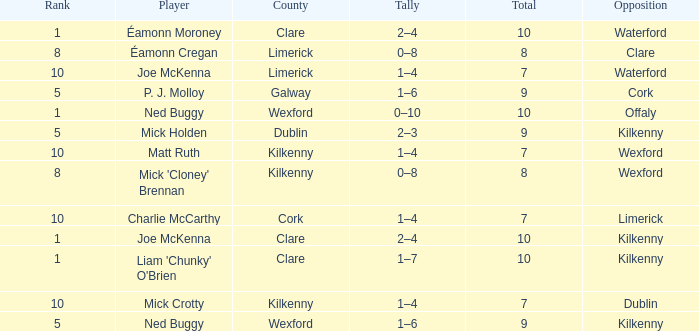Which Total has a County of kilkenny, and a Tally of 1–4, and a Rank larger than 10? None. 